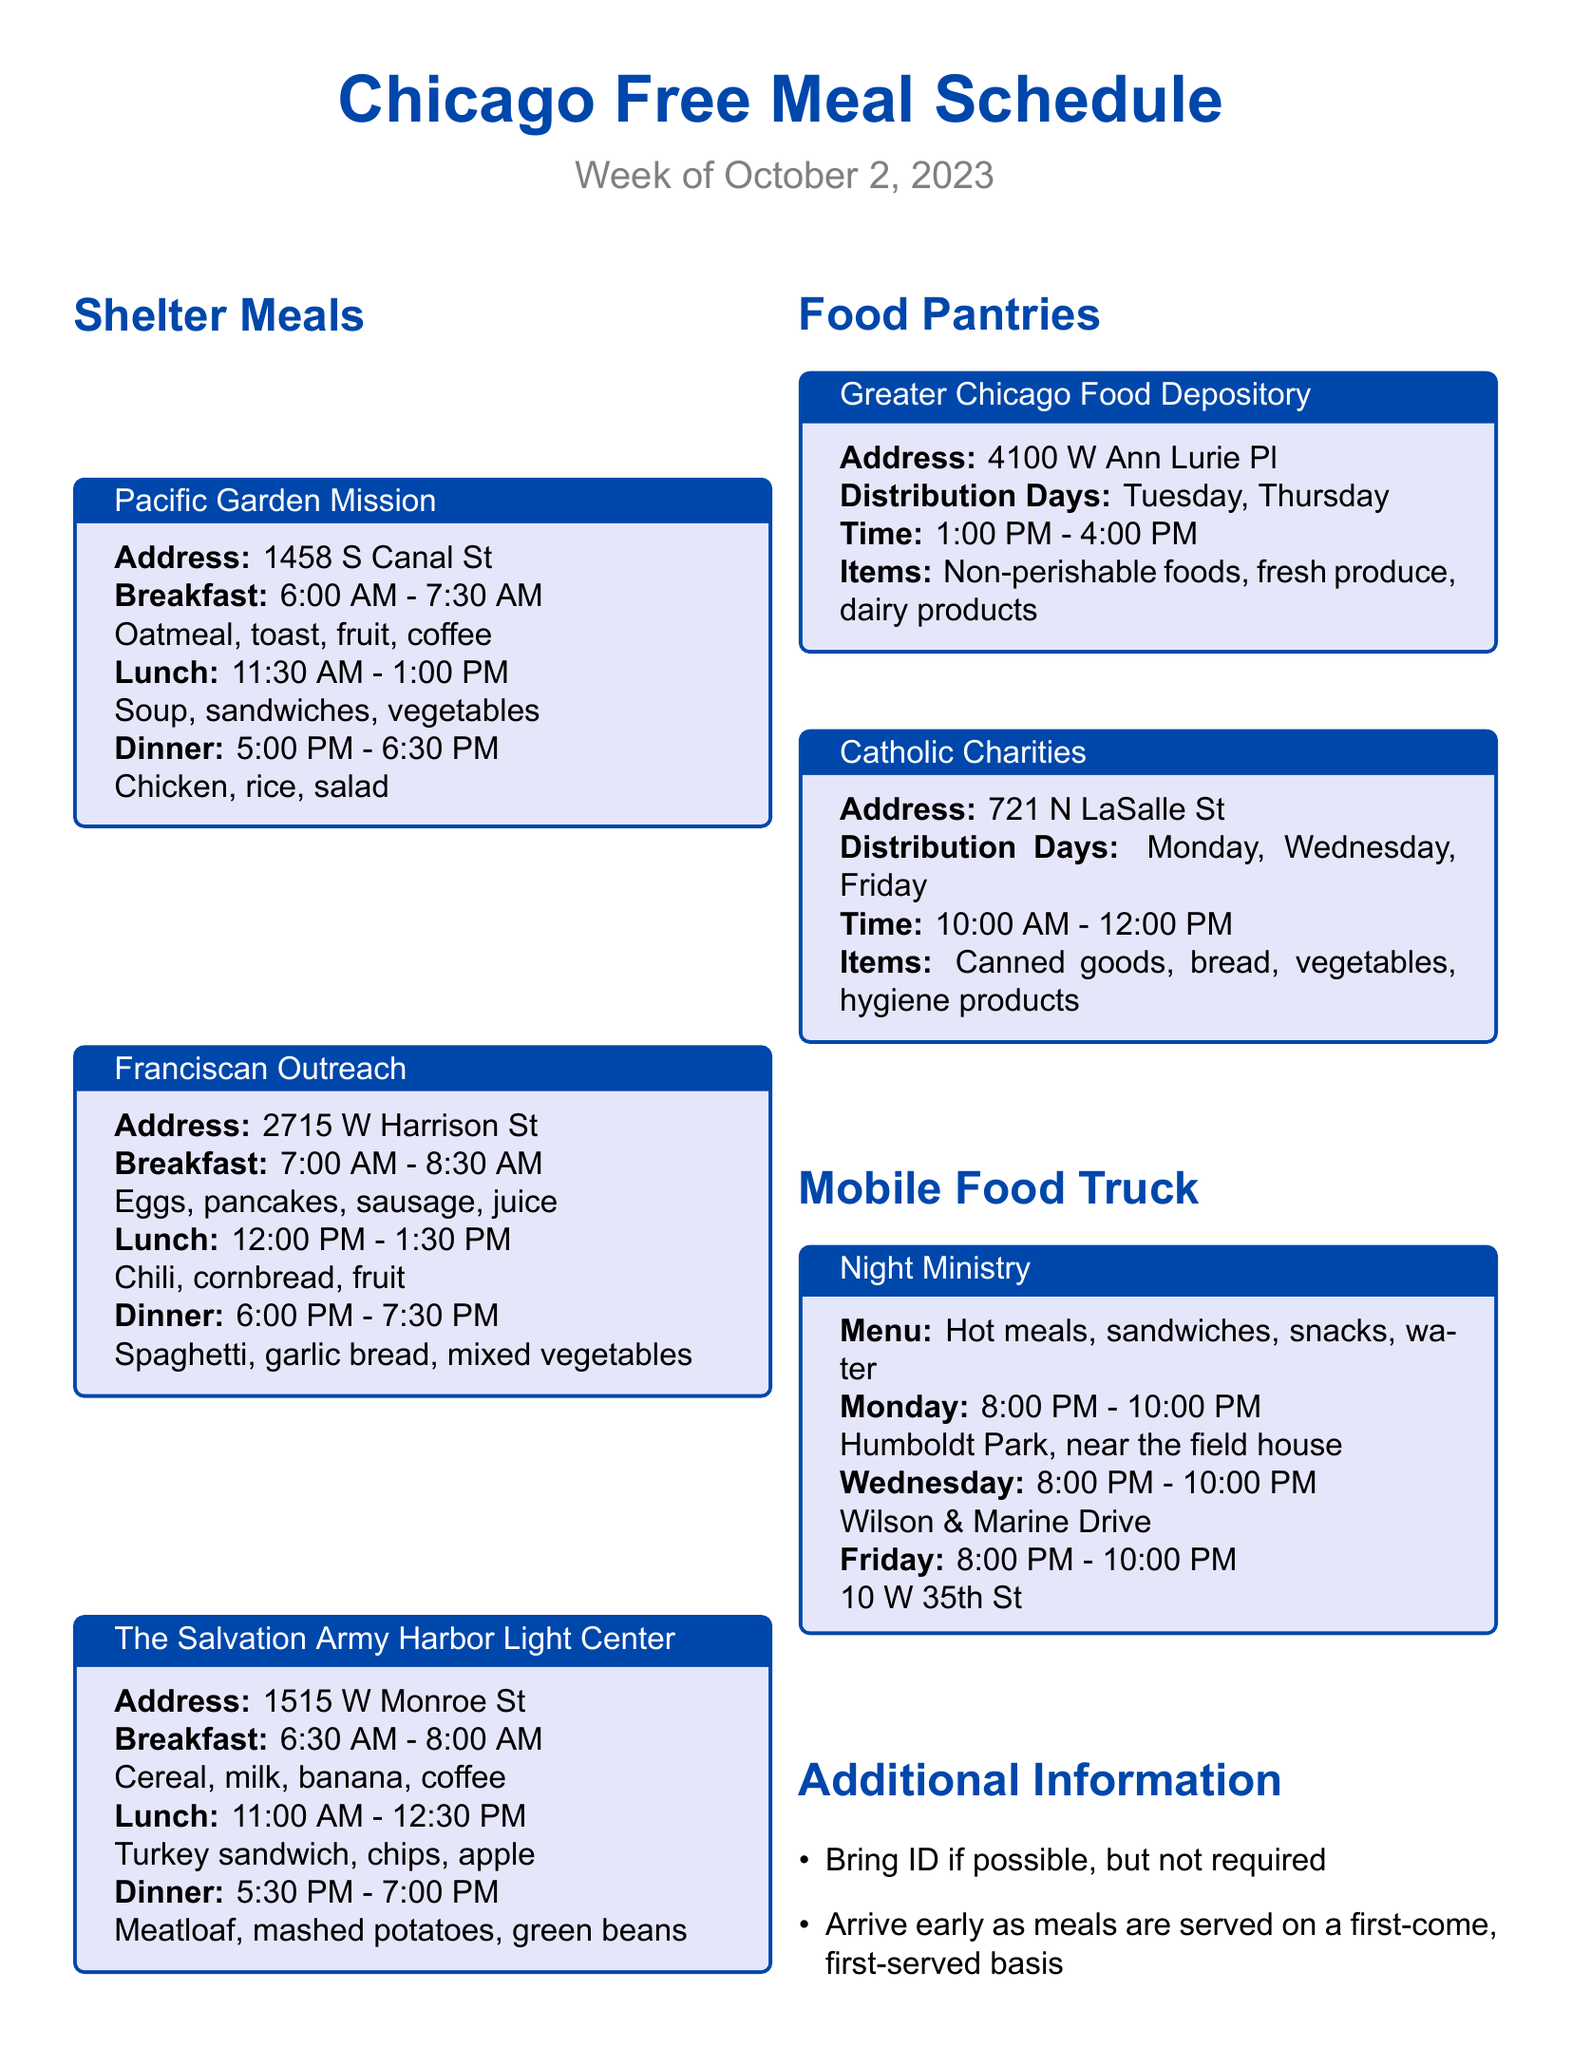What time does breakfast start at Pacific Garden Mission? The breakfast at Pacific Garden Mission starts at 6:00 AM as mentioned in the schedule.
Answer: 6:00 AM What items are available at the Greater Chicago Food Depository? The document lists non-perishable foods, fresh produce, and dairy products as available items at the Greater Chicago Food Depository.
Answer: Non-perishable foods, fresh produce, dairy products How long is the dinner service at The Salvation Army Harbor Light Center? The dinner service at The Salvation Army Harbor Light Center lasts from 5:30 PM to 7:00 PM, which is 1.5 hours.
Answer: 1.5 hours What is the address of Franciscan Outreach? The address of Franciscan Outreach is provided in the document as 2715 W Harrison St.
Answer: 2715 W Harrison St On which days can I visit Catholic Charities? The document indicates that visits to Catholic Charities are available on Monday, Wednesday, and Friday.
Answer: Monday, Wednesday, Friday What type of meals does the Night Ministry mobile food truck serve? According to the document, the Night Ministry serves hot meals, sandwiches, snacks, and water.
Answer: Hot meals, sandwiches, snacks, water Which shelter has the earliest breakfast? The document shows that Pacific Garden Mission has the earliest breakfast at 6:00 AM.
Answer: Pacific Garden Mission What is the distribution time for food pantries on Thursdays? The distribution time for food pantries on Thursdays is 1:00 PM to 4:00 PM, as stated in the information.
Answer: 1:00 PM - 4:00 PM 